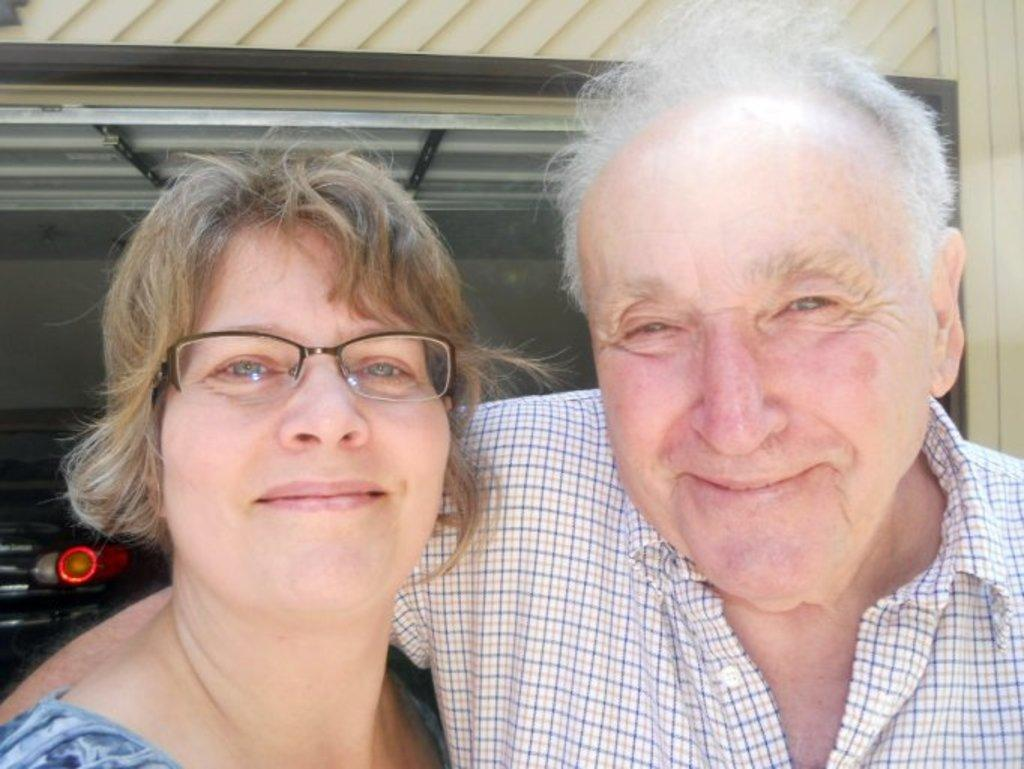How many people are present in the image? There are two people in the image. What can be observed about their clothing? The people are wearing different color dresses. Can you identify any accessories worn by one of the individuals? One person is wearing specs. What can be seen in the background of the image? There is a car inside a shed in the background of the image. What type of volleyball game is being played in the image? There is no volleyball game present in the image. How much income does the person wearing specs earn? The income of the person wearing specs cannot be determined from the image. 